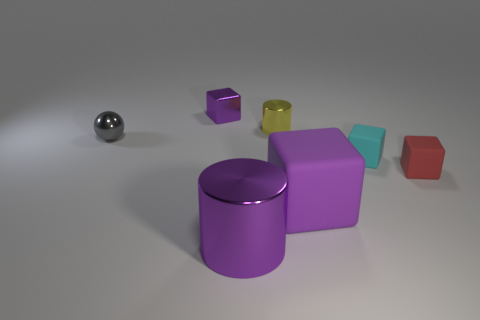Does the small red rubber thing have the same shape as the tiny purple shiny thing?
Give a very brief answer. Yes. Are there an equal number of large things that are to the right of the purple rubber object and small red rubber blocks behind the tiny red block?
Give a very brief answer. Yes. The large object that is made of the same material as the tiny cyan thing is what color?
Offer a very short reply. Purple. What number of spheres have the same material as the tiny purple block?
Offer a very short reply. 1. Is the color of the small metal thing that is to the left of the small purple shiny thing the same as the large metal thing?
Offer a terse response. No. How many small matte objects are the same shape as the big shiny thing?
Offer a very short reply. 0. Are there the same number of shiny cylinders in front of the gray metallic ball and big blocks?
Make the answer very short. Yes. The metallic cube that is the same size as the gray sphere is what color?
Give a very brief answer. Purple. Are there any cyan matte objects that have the same shape as the large purple rubber thing?
Give a very brief answer. Yes. What is the big thing left of the big purple object that is behind the purple metal object that is in front of the purple metal block made of?
Offer a terse response. Metal. 